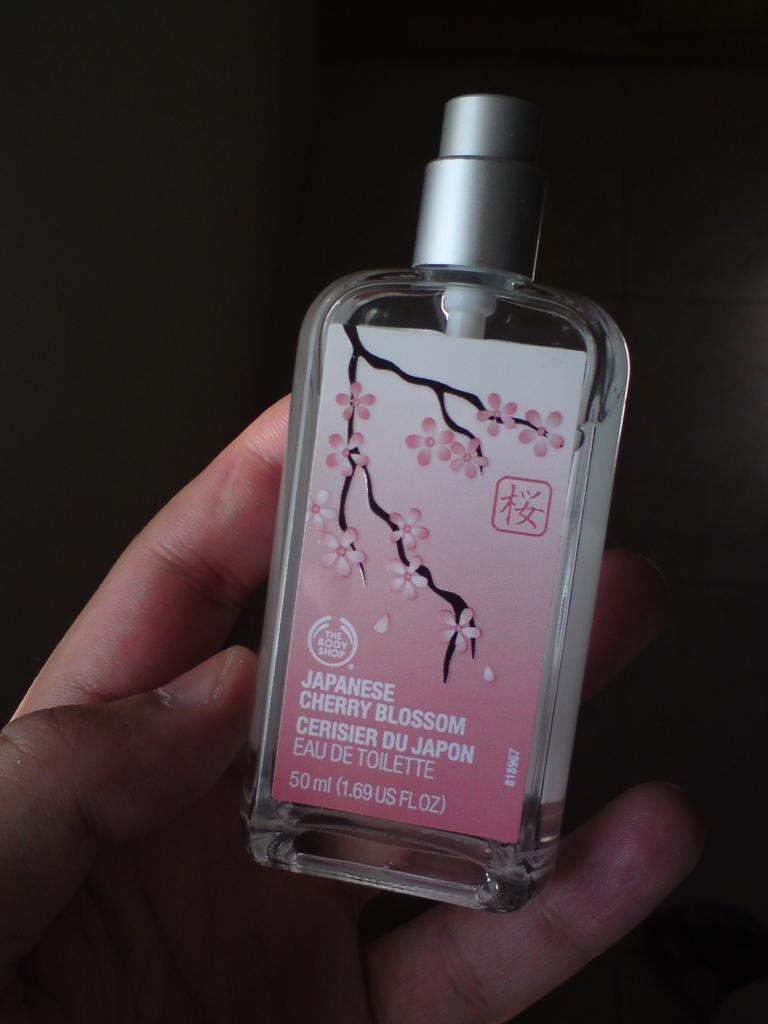<image>
Give a short and clear explanation of the subsequent image. A person is holding a bottle of Japanese Cherry Blossom body perfume. 